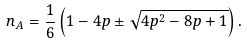<formula> <loc_0><loc_0><loc_500><loc_500>n _ { A } = \frac { 1 } { 6 } \left ( 1 - 4 p \pm \sqrt { 4 p ^ { 2 } - 8 p + 1 } \right ) .</formula> 